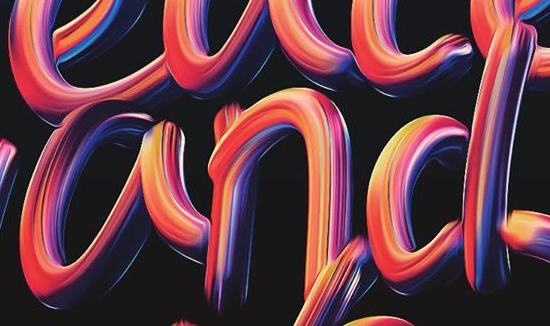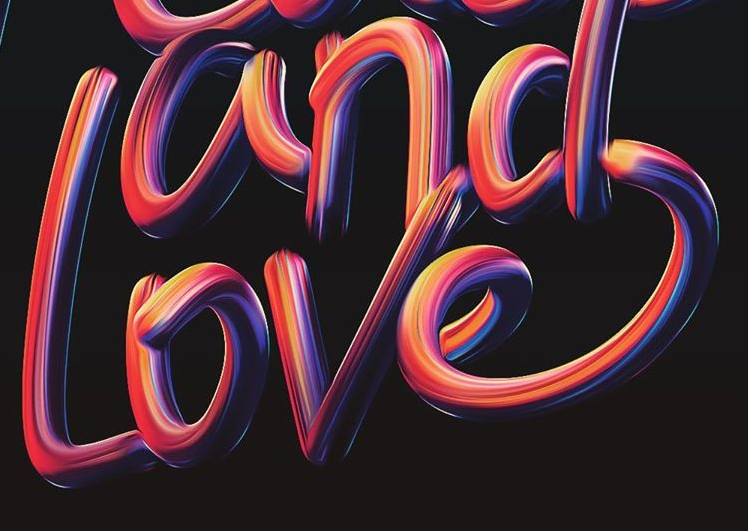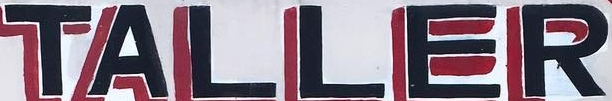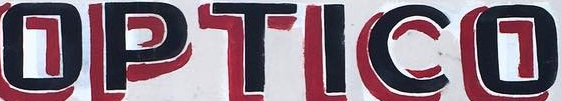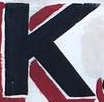Identify the words shown in these images in order, separated by a semicolon. and; Love; TALLER; OPTICO; K 